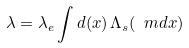Convert formula to latex. <formula><loc_0><loc_0><loc_500><loc_500>\lambda = \lambda _ { e } \int d ( x ) \, \Lambda _ { s } ( \ m d x ) \,</formula> 